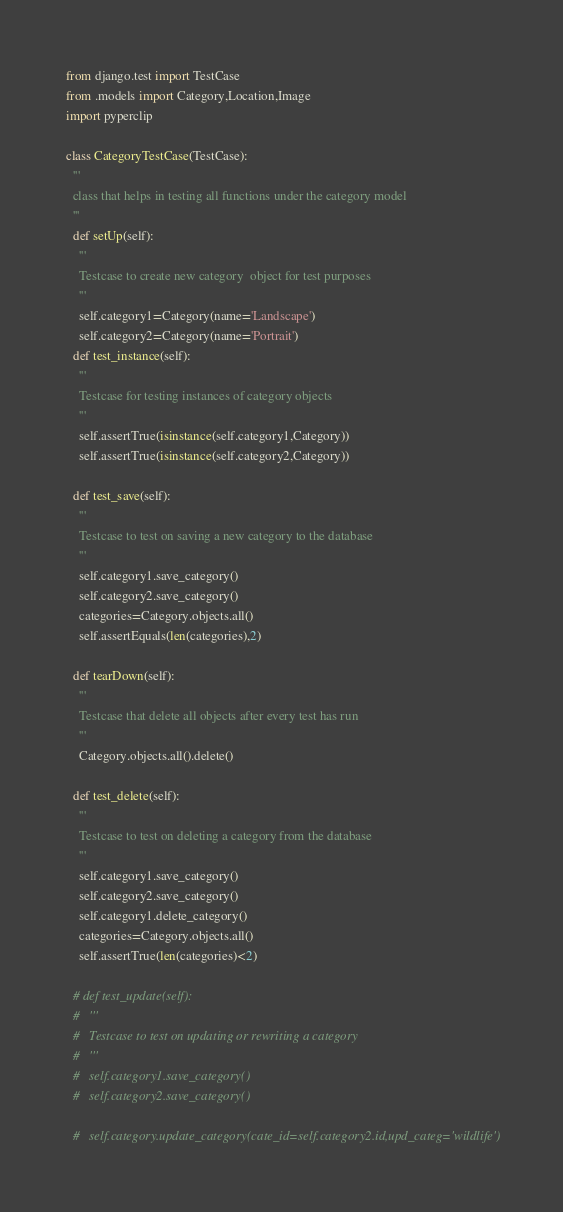<code> <loc_0><loc_0><loc_500><loc_500><_Python_>from django.test import TestCase
from .models import Category,Location,Image
import pyperclip

class CategoryTestCase(TestCase):
  '''
  class that helps in testing all functions under the category model
  '''
  def setUp(self):
    '''
    Testcase to create new category  object for test purposes
    '''
    self.category1=Category(name='Landscape')
    self.category2=Category(name='Portrait')
  def test_instance(self):
    '''
    Testcase for testing instances of category objects
    '''
    self.assertTrue(isinstance(self.category1,Category))
    self.assertTrue(isinstance(self.category2,Category))

  def test_save(self):
    '''
    Testcase to test on saving a new category to the database
    '''
    self.category1.save_category()
    self.category2.save_category()
    categories=Category.objects.all()
    self.assertEquals(len(categories),2)

  def tearDown(self):   
    '''
    Testcase that delete all objects after every test has run
    ''' 
    Category.objects.all().delete()
    
  def test_delete(self):
    '''
    Testcase to test on deleting a category from the database
    '''
    self.category1.save_category()
    self.category2.save_category()    
    self.category1.delete_category()
    categories=Category.objects.all()
    self.assertTrue(len(categories)<2)

  # def test_update(self):
  #   '''
  #   Testcase to test on updating or rewriting a category
  #   '''
  #   self.category1.save_category()
  #   self.category2.save_category()

  #   self.category.update_category(cate_id=self.category2.id,upd_categ='wildlife')
</code> 